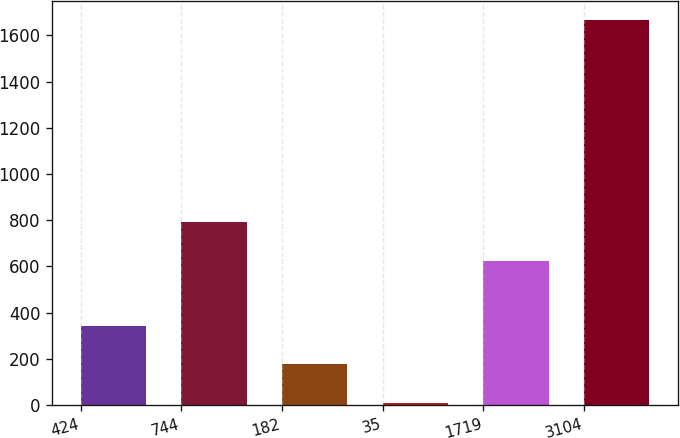<chart> <loc_0><loc_0><loc_500><loc_500><bar_chart><fcel>424<fcel>744<fcel>182<fcel>35<fcel>1719<fcel>3104<nl><fcel>341.66<fcel>790.33<fcel>176.03<fcel>10.4<fcel>624.7<fcel>1666.7<nl></chart> 